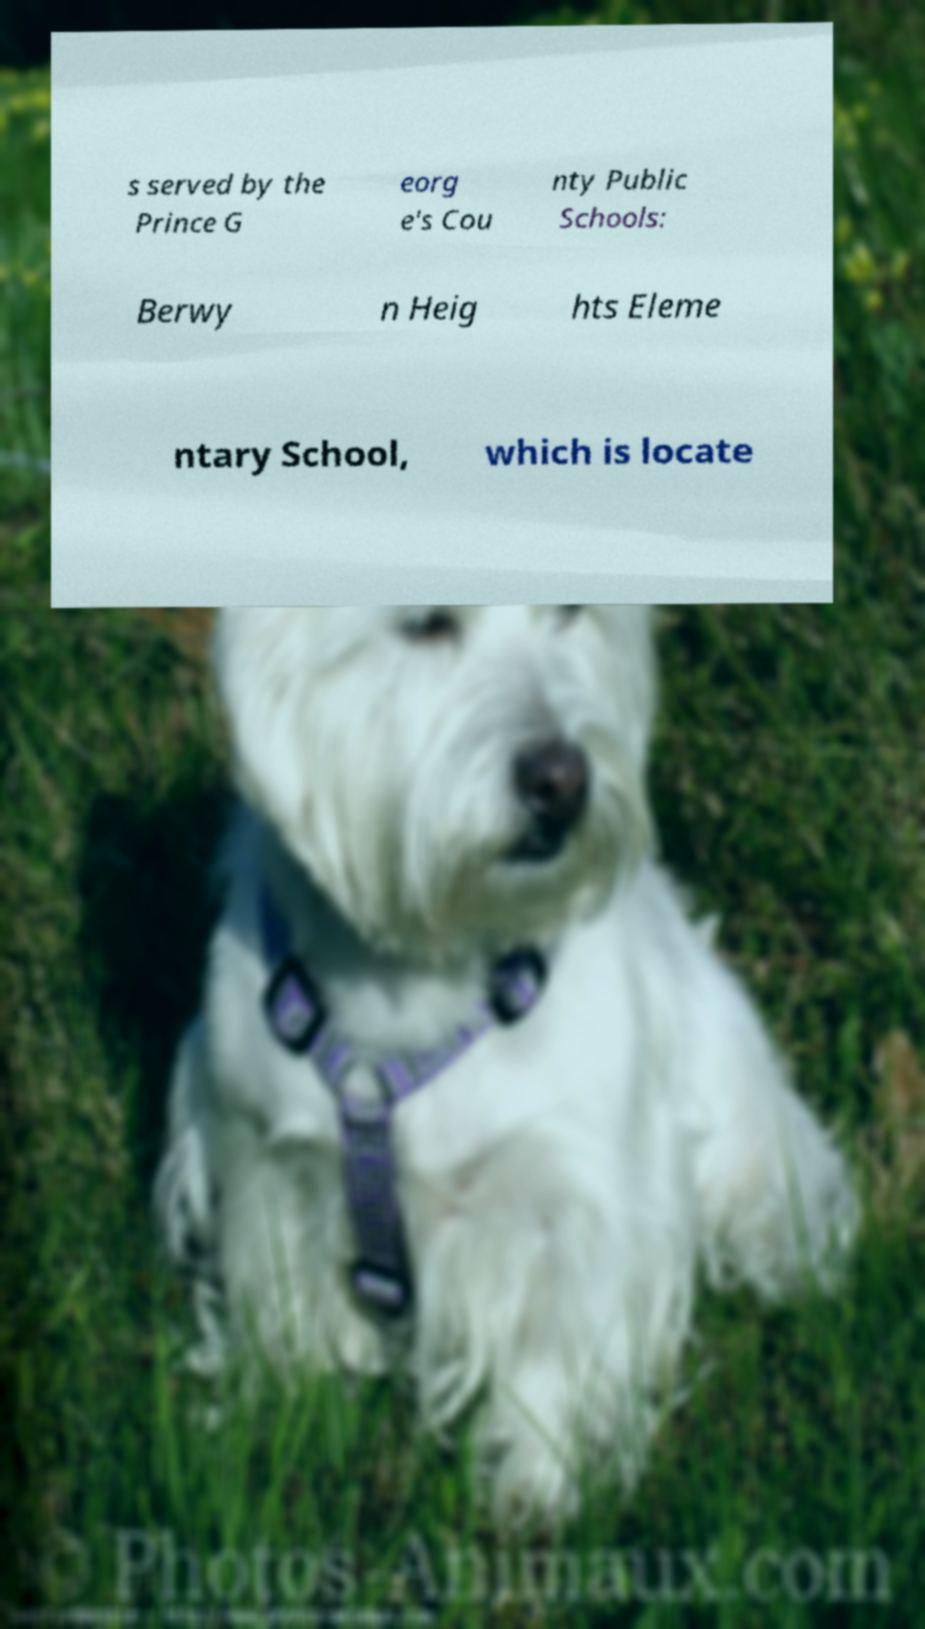There's text embedded in this image that I need extracted. Can you transcribe it verbatim? s served by the Prince G eorg e's Cou nty Public Schools: Berwy n Heig hts Eleme ntary School, which is locate 